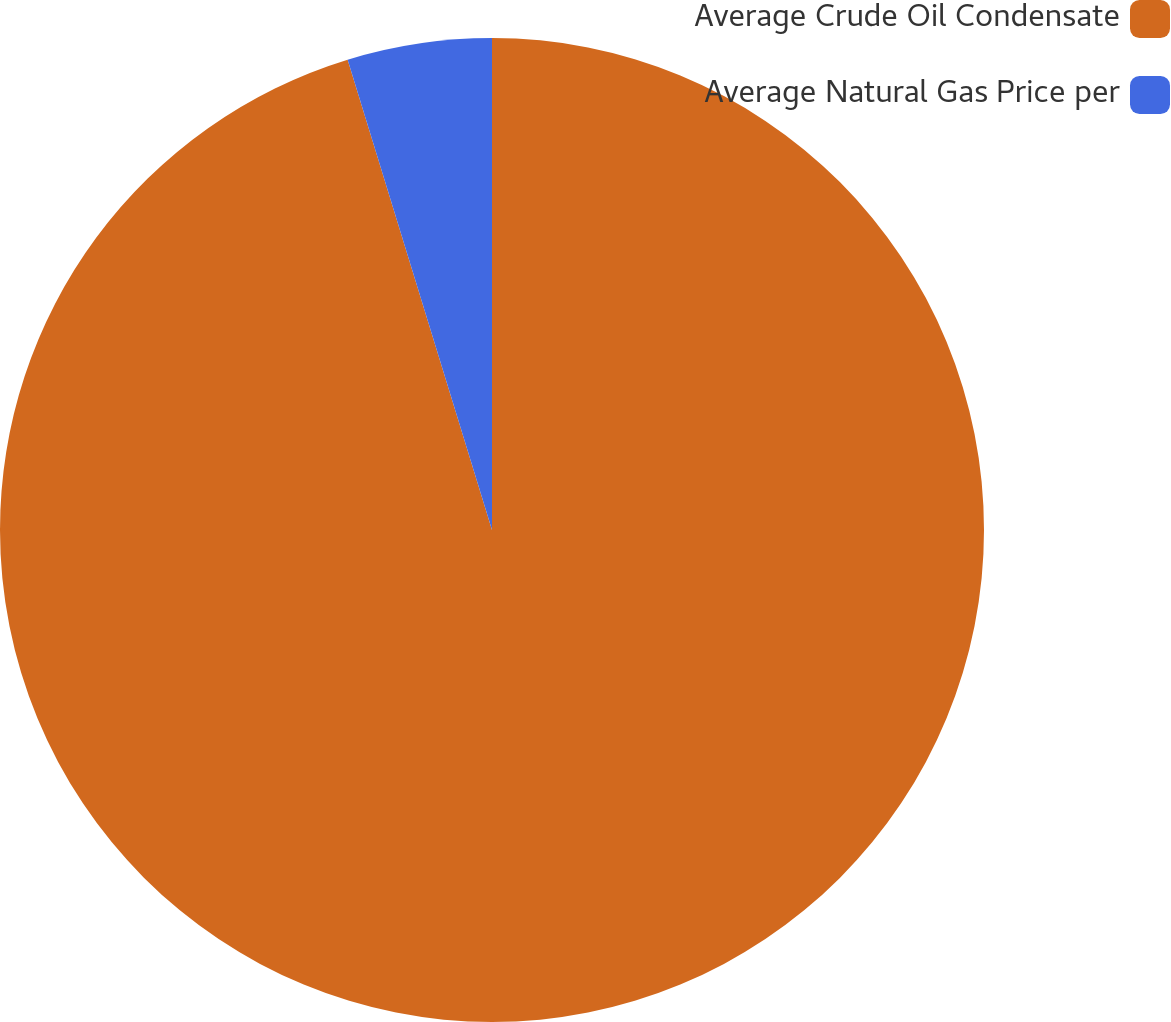Convert chart. <chart><loc_0><loc_0><loc_500><loc_500><pie_chart><fcel>Average Crude Oil Condensate<fcel>Average Natural Gas Price per<nl><fcel>95.26%<fcel>4.74%<nl></chart> 